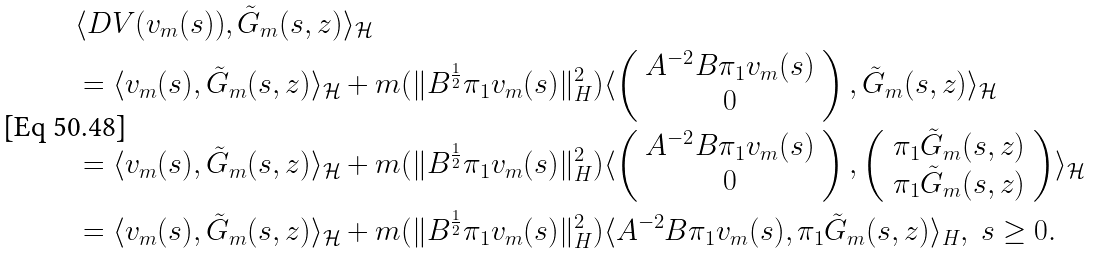Convert formula to latex. <formula><loc_0><loc_0><loc_500><loc_500>& \langle D V ( v _ { m } ( s ) ) , \tilde { G } _ { m } ( s , z ) \rangle _ { \mathcal { H } } \\ & = \langle v _ { m } ( s ) , \tilde { G } _ { m } ( s , z ) \rangle _ { \mathcal { H } } + m ( \| B ^ { \frac { 1 } { 2 } } \pi _ { 1 } v _ { m } ( s ) \| ^ { 2 } _ { H } ) \langle \left ( \begin{array} { c } A ^ { - 2 } B \pi _ { 1 } v _ { m } ( s ) \\ 0 \end{array} \right ) , \tilde { G } _ { m } ( s , z ) \rangle _ { \mathcal { H } } \\ & = \langle v _ { m } ( s ) , \tilde { G } _ { m } ( s , z ) \rangle _ { \mathcal { H } } + m ( \| B ^ { \frac { 1 } { 2 } } \pi _ { 1 } v _ { m } ( s ) \| ^ { 2 } _ { H } ) \langle \left ( \begin{array} { c } A ^ { - 2 } B \pi _ { 1 } v _ { m } ( s ) \\ 0 \end{array} \right ) , \left ( \begin{array} { c } \pi _ { 1 } \tilde { G } _ { m } ( s , z ) \\ \pi _ { 1 } \tilde { G } _ { m } ( s , z ) \end{array} \right ) \rangle _ { \mathcal { H } } \\ & = \langle v _ { m } ( s ) , \tilde { G } _ { m } ( s , z ) \rangle _ { \mathcal { H } } + m ( \| B ^ { \frac { 1 } { 2 } } \pi _ { 1 } v _ { m } ( s ) \| ^ { 2 } _ { H } ) \langle A ^ { - 2 } B \pi _ { 1 } v _ { m } ( s ) , \pi _ { 1 } \tilde { G } _ { m } ( s , z ) \rangle _ { H } , \ s \geq 0 .</formula> 